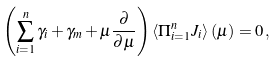<formula> <loc_0><loc_0><loc_500><loc_500>\left ( \sum _ { i = 1 } ^ { n } \gamma _ { i } + \gamma _ { m } + \mu \frac { \partial } { \partial \mu } \right ) \left \langle \Pi _ { i = 1 } ^ { n } J _ { i } \right \rangle ( \mu ) = 0 \, ,</formula> 